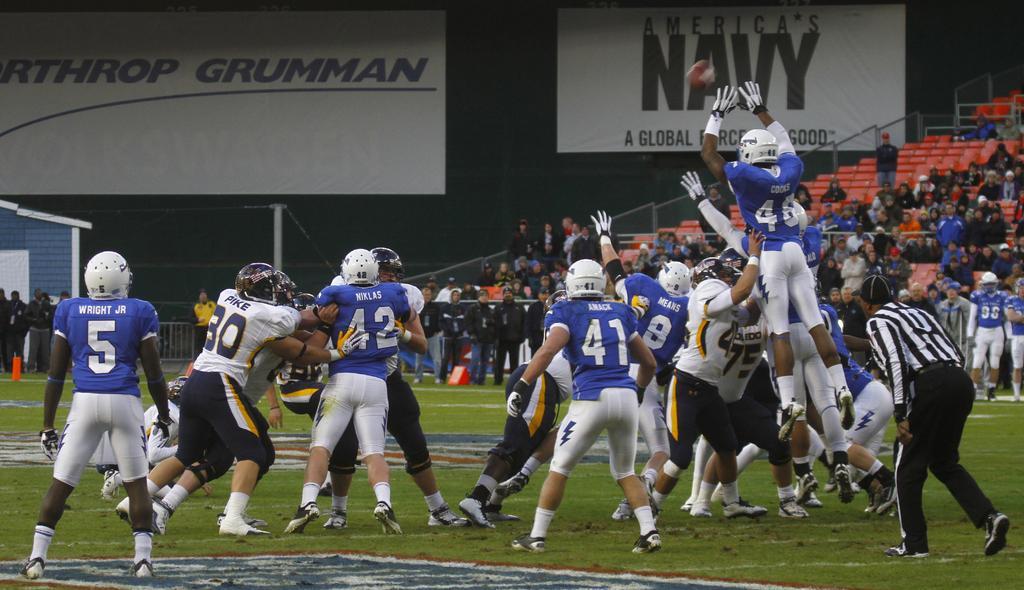How would you summarize this image in a sentence or two? In the foreground of this image, there are people playing rugby, where men are standing, walking on the grass and also there is a man and a ball in the air. In the background, there are few standing and many are sitting on the chairs and there is railing, few banners, a pole and an objects on the left side. 